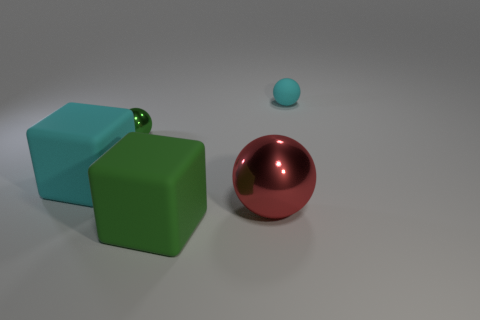What material is the other thing that is the same color as the tiny metal thing? In the image, the small metallic sphere seems to share its color with the larger glossy ball. While the initial answer was 'rubber,' upon closer inspection, the larger object's reflective surface and smooth texture suggest that it could be made of polished metal or a similarly smooth and reflective material, rather than rubber. 